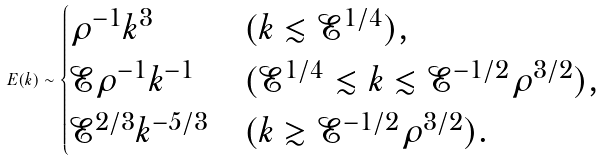<formula> <loc_0><loc_0><loc_500><loc_500>E ( k ) \sim \begin{cases} \rho ^ { - 1 } k ^ { 3 } & ( k \lesssim \mathcal { E } ^ { 1 / 4 } ) , \\ \mathcal { E } \rho ^ { - 1 } k ^ { - 1 } & ( \mathcal { E } ^ { 1 / 4 } \lesssim k \lesssim \mathcal { E } ^ { - 1 / 2 } \rho ^ { 3 / 2 } ) , \\ \mathcal { E } ^ { 2 / 3 } k ^ { - 5 / 3 } & ( k \gtrsim \mathcal { E } ^ { - 1 / 2 } \rho ^ { 3 / 2 } ) . \end{cases}</formula> 